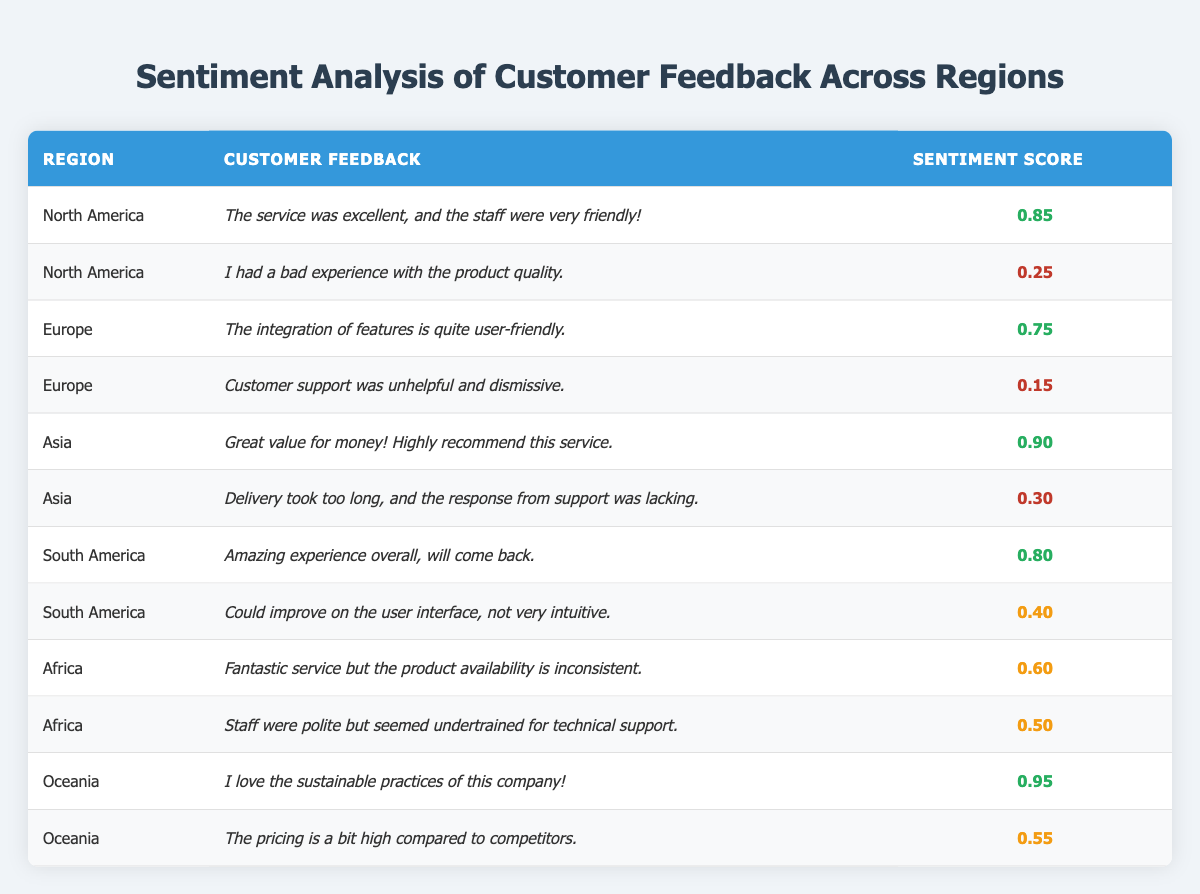What is the highest sentiment score among the regions? The highest sentiment score available in the table is found by comparing all the sentiment scores listed across the regions. The highest score is 0.95 for Oceania.
Answer: 0.95 Which region has feedback indicating a bad experience with product quality? The feedback that indicates a bad experience with product quality comes from North America, where the sentiment score is 0.25.
Answer: North America What is the average sentiment score for customer feedback from Asia? The sentiment scores from Asia are 0.90 (positive feedback) and 0.30 (negative feedback). To find the average, sum the scores: 0.90 + 0.30 = 1.20. Then divide by 2 (the number of scores): 1.20 / 2 = 0.60.
Answer: 0.60 Is there any feedback in Europe that indicates a high level of customer satisfaction? In the Europe region, the feedback with a high sentiment score of 0.75 signifies a positive experience, while the other feedback with a score of 0.15 indicates dissatisfaction. Therefore, yes, there is feedback indicating high satisfaction.
Answer: Yes What is the difference in sentiment score between the highest and lowest scores in South America? The highest sentiment score in South America is from the feedback with a score of 0.80 (positive experience) and the lowest is 0.40 (medium score for user interface issues). Thus, the difference is 0.80 - 0.40 = 0.40.
Answer: 0.40 How many regions have a sentiment score below 0.30? By examining the table, the sentiment scores below 0.30 are 0.25 (North America) and 0.15 (Europe), which makes a total of 2 instances from different regions.
Answer: 2 Which region has the least favorable feedback based on sentiment scores? The region with the least favorable feedback is Europe, with the lowest sentiment score of 0.15, indicating a highly negative experience according to the feedback.
Answer: Europe How many feedback instances in Oceania indicate positive sentiments? In Oceania, there are two feedback instances with sentiment scores of 0.95 (very positive sentiment) and 0.55 (medium sentiment). Both can be considered positive sentiments, resulting in a total of 2 instances.
Answer: 2 Is customer support feedback in Africa generally negative? The sentiment score for the feedback in Africa is 0.50 and 0.60, indicating moderate sentiment. Since neither feedback is below 0.50, we cannot categorize them as entirely negative.
Answer: No 